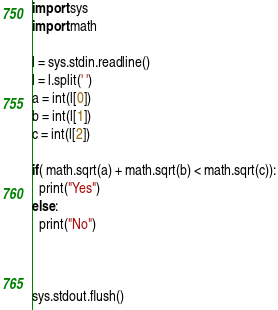<code> <loc_0><loc_0><loc_500><loc_500><_Python_>import sys
import math

l = sys.stdin.readline()
l = l.split(' ')
a = int(l[0])
b = int(l[1])
c = int(l[2])

if( math.sqrt(a) + math.sqrt(b) < math.sqrt(c)):
  print("Yes")
else:
  print("No")



sys.stdout.flush()
</code> 